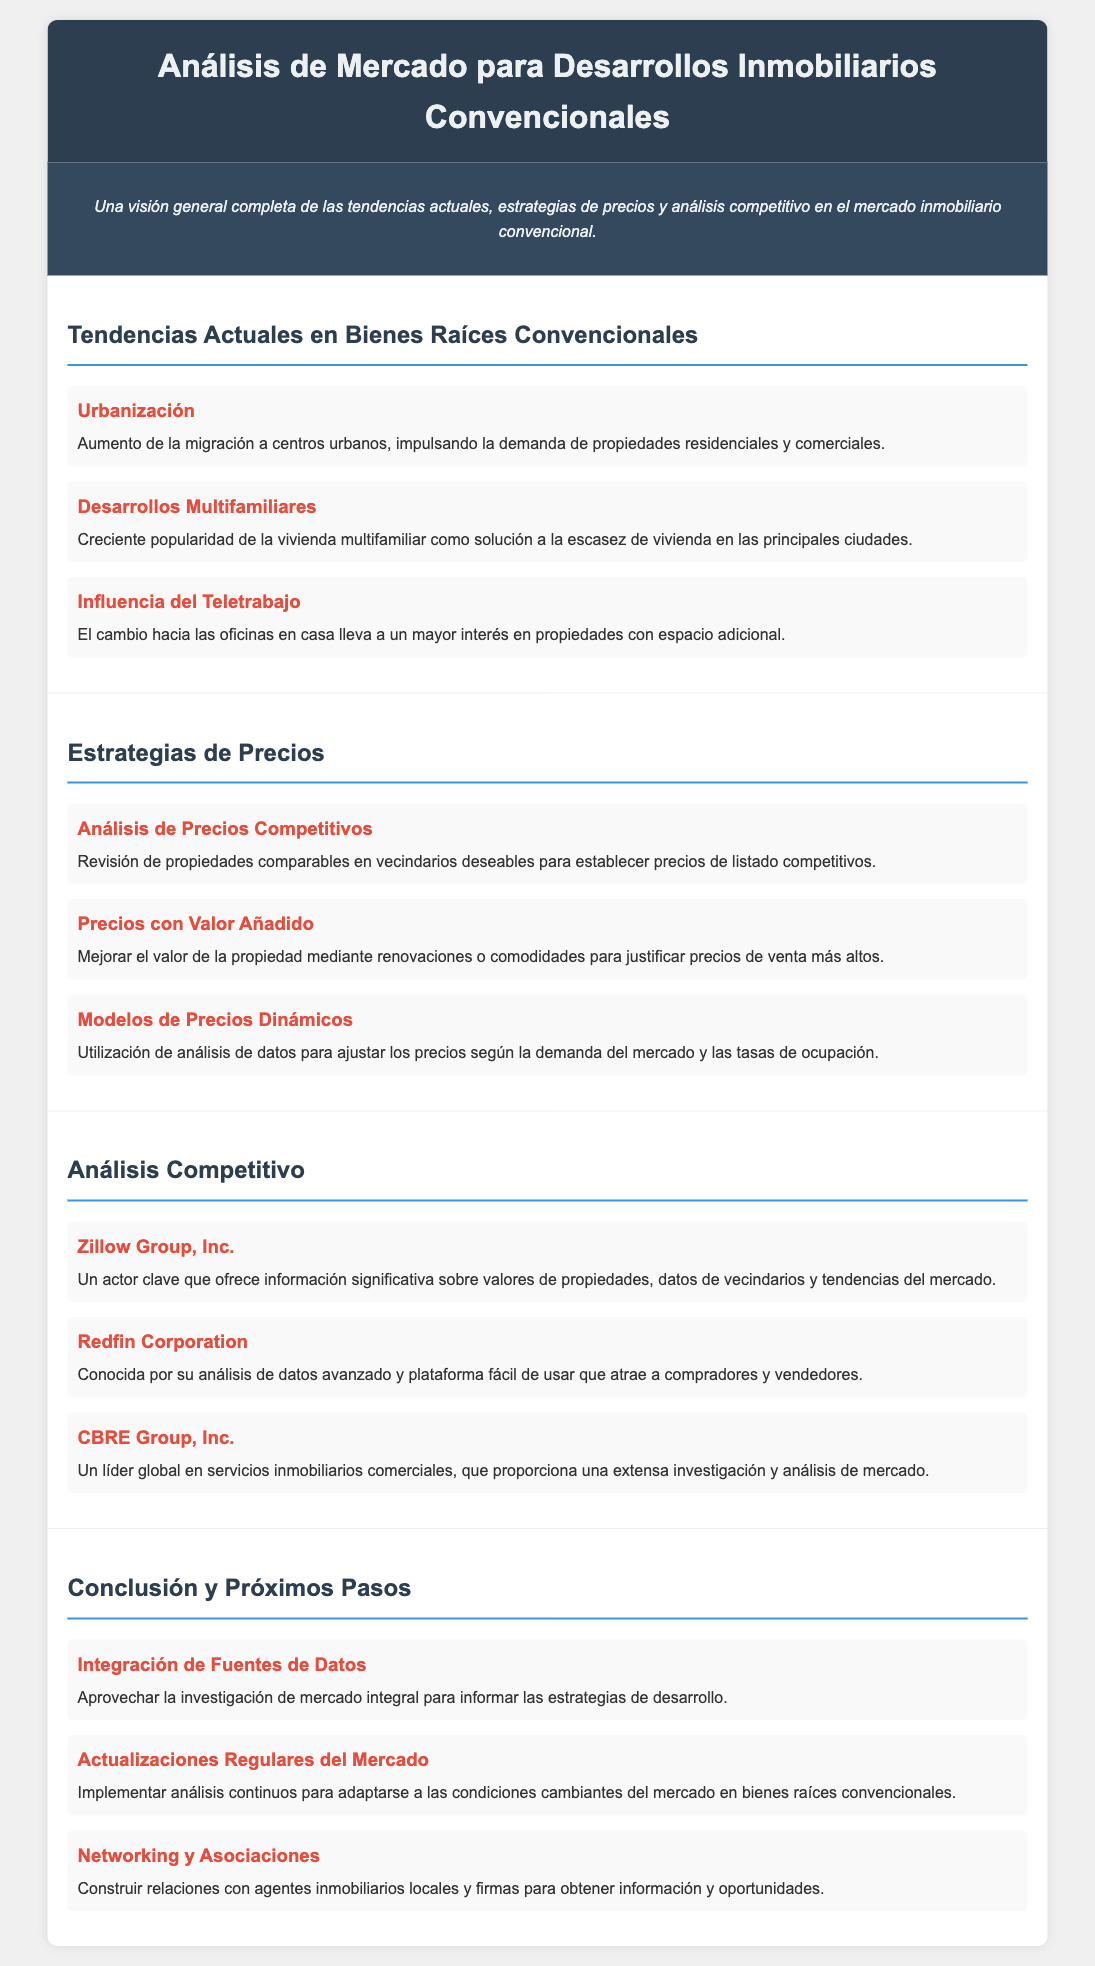¿Cuáles son las tendencias actuales en bienes raíces convencionales? Las tendencias actuales en bienes raíces convencionales incluyen la urbanización, desarrollos multifamiliares e influencia del teletrabajo.
Answer: Urbanización, desarrollos multifamiliares, influencia del teletrabajo ¿Qué actor clave en el análisis competitivo ofrece información sobre datos de vecindarios? El documento menciona a Zillow Group, Inc. como un actor clave que ofrece información significativa sobre valores de propiedades y datos de vecindarios.
Answer: Zillow Group, Inc ¿Cuál es una estrategia de precios para justificar precios de venta más altos? Se menciona que mejorar el valor de la propiedad mediante renovaciones o comodidades puede justificar precios de venta más altos.
Answer: Mejora del valor mediante renovaciones o comodidades ¿Cuántas secciones hay en el documento? Al contar las secciones del documento, se observa que hay cuatro secciones principales: tendencias actuales, estrategias de precios, análisis competitivo y conclusión.
Answer: Cuatro ¿Qué se menciona como una influencia en el mercado debido al teletrabajo? Se hace referencia a que el cambio hacia oficinas en casa lleva a un mayor interés en propiedades con espacio adicional.
Answer: Mayor interés en propiedades con espacio adicional 